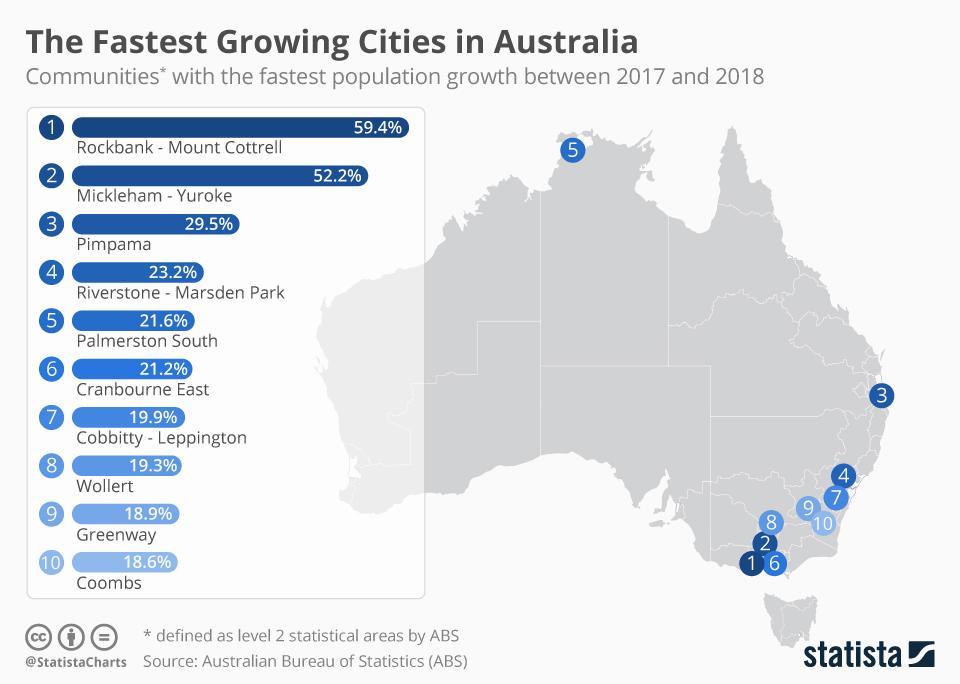List a handful of essential elements in this visual. After Mickleham-Yuroke, which is the next fastest growing city in Australia? Pimpama. Riverstone-Marsden Park is experiencing a growth rate of 23.2%. Out of the cities considered, two have experienced growth above 50%. The city of Palmerston South is the farthest growing compared to others. 